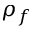<formula> <loc_0><loc_0><loc_500><loc_500>\rho _ { f }</formula> 